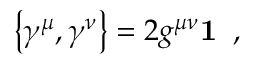<formula> <loc_0><loc_0><loc_500><loc_500>\left \{ \gamma ^ { \mu } , \gamma ^ { \nu } \right \} = 2 g ^ { \mu \nu } { 1 } \, ,</formula> 